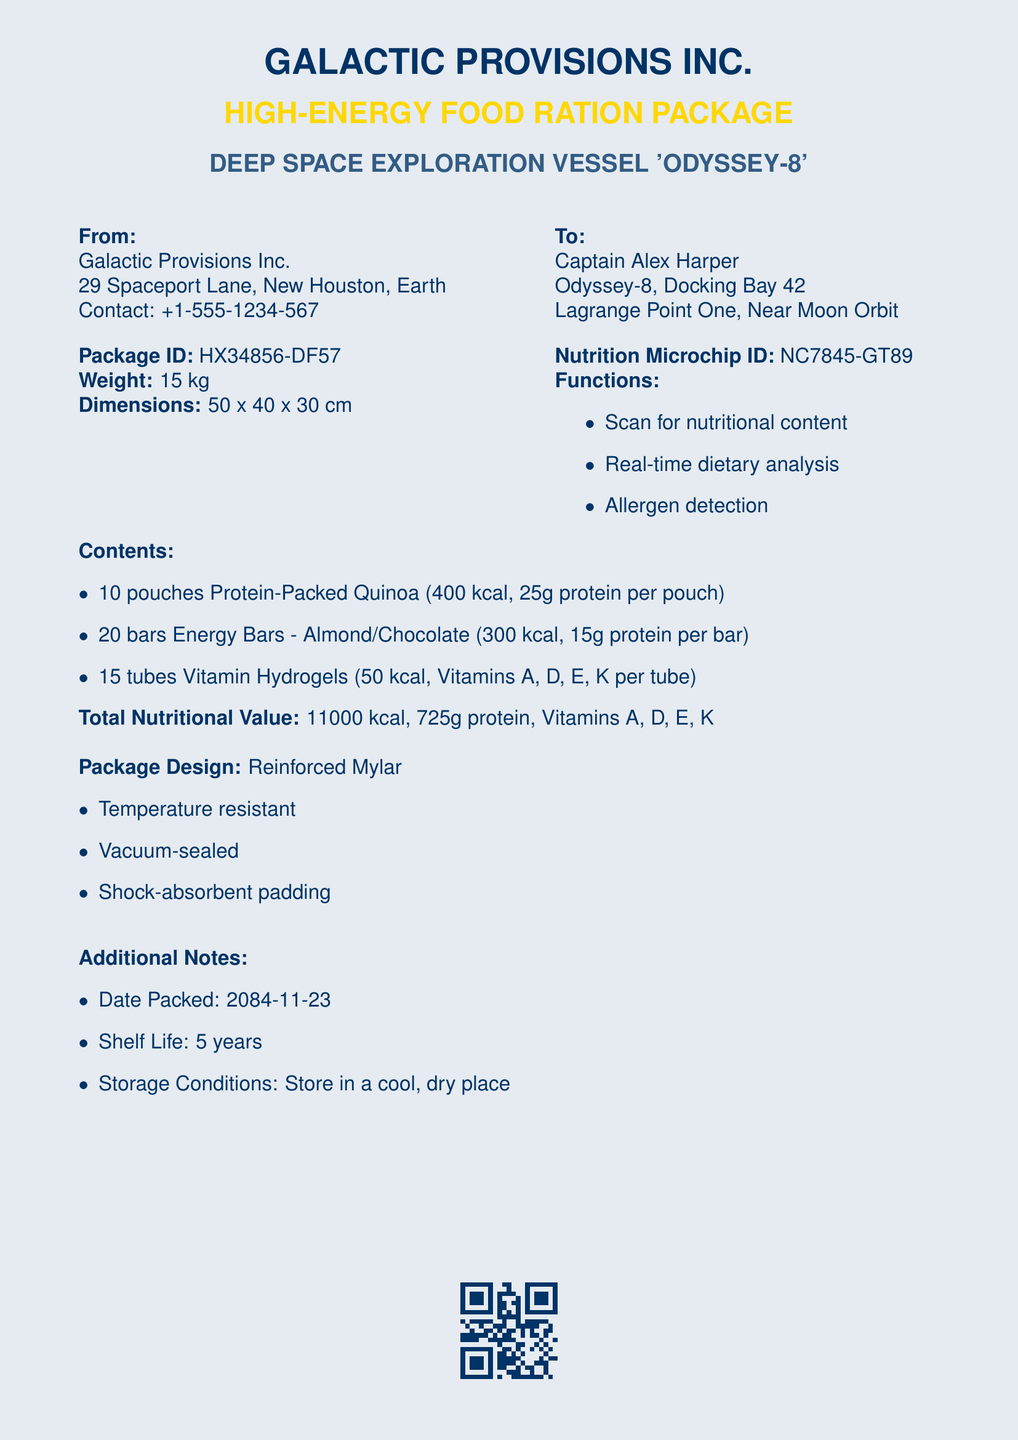What is the package weight? The weight of the package is specified as 15 kg in the document.
Answer: 15 kg Who is the recipient of the package? The document indicates that the package is addressed to Captain Alex Harper.
Answer: Captain Alex Harper What is the nutrition microchip ID? The Nutrition Microchip ID is provided as NC7845-GT89.
Answer: NC7845-GT89 How many pouches of Protein-Packed Quinoa are included? The document lists 10 pouches of Protein-Packed Quinoa as part of the contents.
Answer: 10 pouches What is the total caloric value of the package? The total nutritional value is stated as 11000 kcal in the document.
Answer: 11000 kcal What date was the package packed? The packing date is noted as 2084-11-23 in the additional notes section.
Answer: 2084-11-23 What type of materials is the package design made of? The package design is specified to be made of Reinforced Mylar.
Answer: Reinforced Mylar What storage conditions are recommended? The document advises to store the package in a cool, dry place.
Answer: Cool, dry place How many energy bars are included? The number of Energy Bars included is mentioned as 20 bars.
Answer: 20 bars 